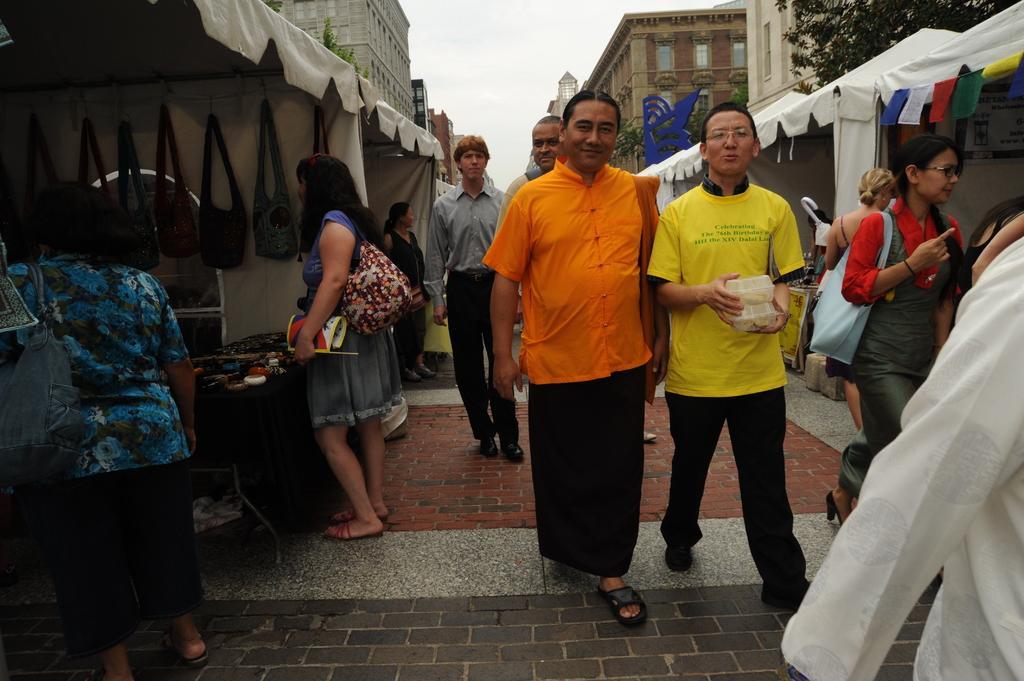Please provide a concise description of this image. This is the picture of a road. In this image there are group of people walking on the road. On the left side of the image there are group of people standing and there are objects on the table and there are bags hanging. At the back there are buildings and tents and trees. At the top there is sky. At the bottom there is a road. 